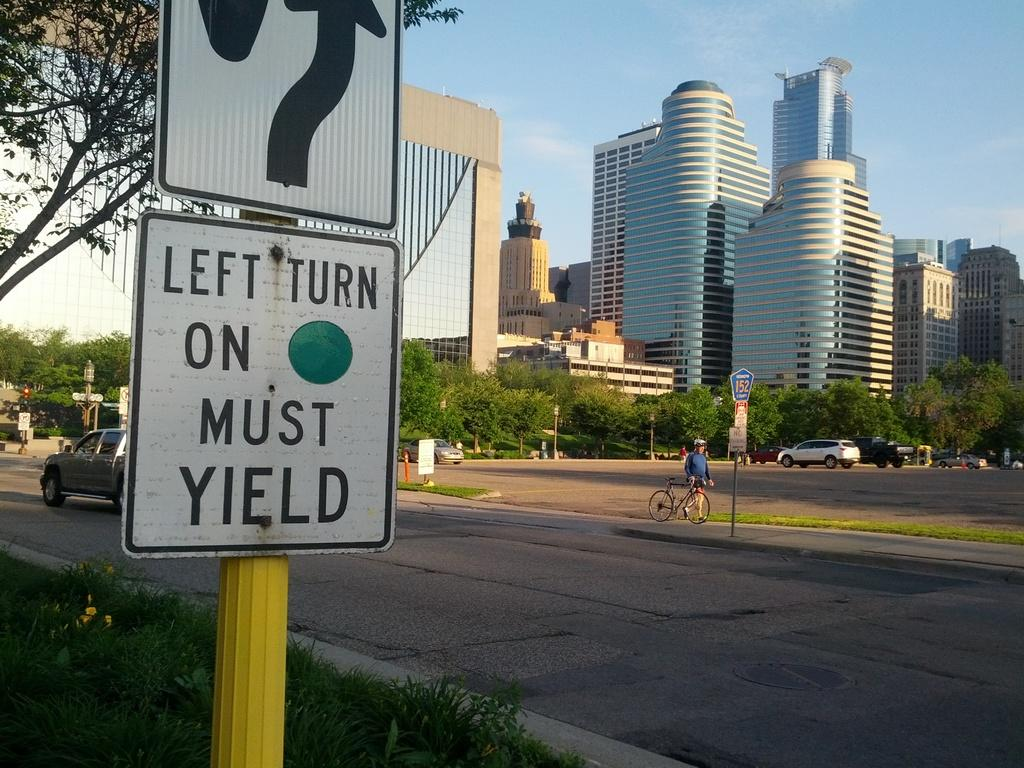<image>
Provide a brief description of the given image. A street sign that says left turn on green must yield. 